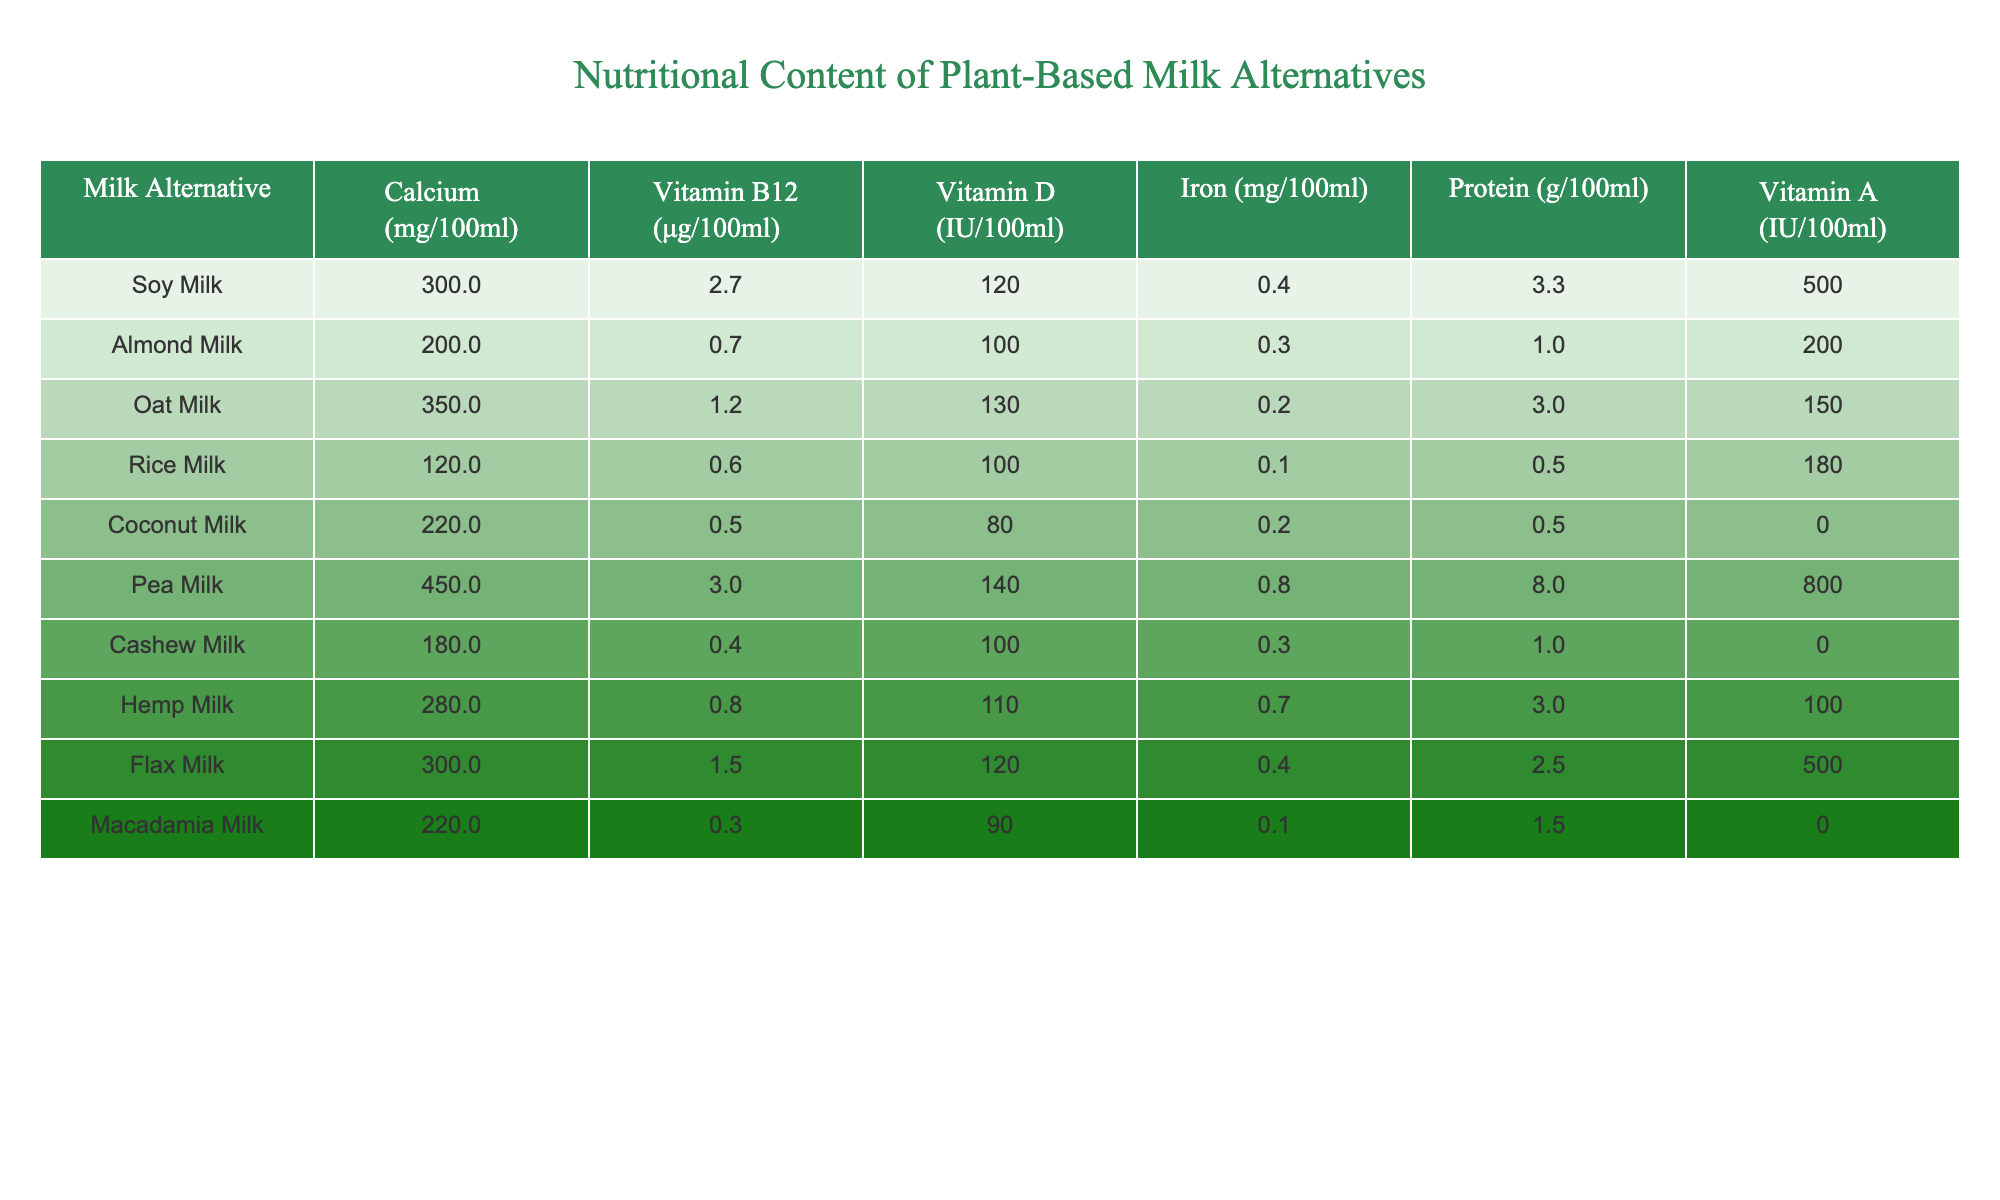What type of plant-based milk alternative has the highest calcium content? Looking at the table, Pea Milk has the highest calcium content at 450 mg per 100 ml.
Answer: Pea Milk Which plant-based milk alternative contains the most protein? By comparing the protein values in the table, Pea Milk has the highest protein content at 8.0 g per 100 ml.
Answer: Pea Milk Is there any plant-based milk alternative with vitamin B12 content greater than 2 μg per 100 ml? Yes, both Soy Milk (2.7 μg) and Pea Milk (3.0 μg) contain more than 2 μg of vitamin B12 per 100 ml.
Answer: Yes What is the average vitamin D content of all the plant-based milk alternatives listed? The total vitamin D content is 120 + 100 + 130 + 100 + 80 + 140 + 100 + 110 + 120 + 90 = 1,120 IU. Divided by 10, the average is 112 IU.
Answer: 112 IU Which plant-based milk alternative has the lowest iron content? Rice Milk has the lowest iron content with only 0.1 mg per 100 ml.
Answer: Rice Milk Is Almond Milk higher in calcium content than Rice Milk? Yes, Almond Milk has 200 mg of calcium, while Rice Milk only has 120 mg.
Answer: Yes What is the total iron content of Oat Milk and Flax Milk combined? Oat Milk has 0.2 mg of iron and Flax Milk has 0.4 mg. Combined they total 0.2 + 0.4 = 0.6 mg.
Answer: 0.6 mg What percentage of the vitamin A in Pea Milk is greater than that in Coconut Milk? Pea Milk contains 800 IU of vitamin A, while Coconut Milk contains none (0 IU), therefore 800 IU is 100% greater.
Answer: 100% Which plant-based milk alternative provides more than 300 mg of calcium and 2 g of protein per 100 ml? Both Soy Milk (300 mg calcium, 3.3 g protein) and Pea Milk (450 mg calcium, 8.0 g protein) meet this criterion.
Answer: Soy Milk and Pea Milk What is the most significant difference in protein content between Pea Milk and Rice Milk? Pea Milk has 8.0 g and Rice Milk has 0.5 g. The difference is 8.0 - 0.5 = 7.5 g.
Answer: 7.5 g 